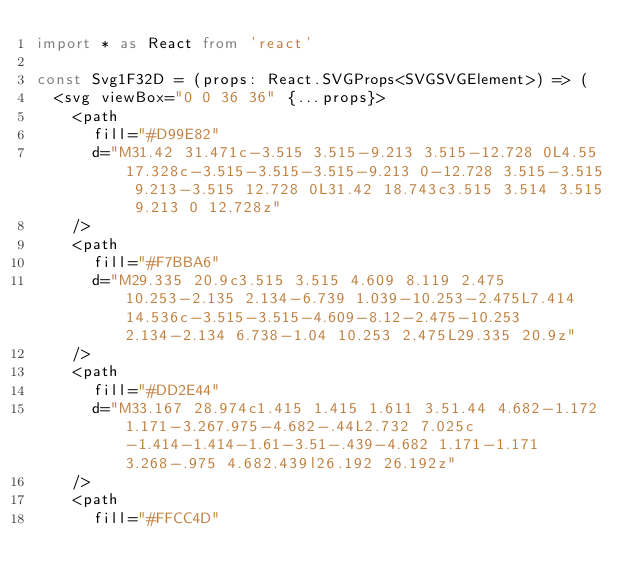Convert code to text. <code><loc_0><loc_0><loc_500><loc_500><_TypeScript_>import * as React from 'react'

const Svg1F32D = (props: React.SVGProps<SVGSVGElement>) => (
  <svg viewBox="0 0 36 36" {...props}>
    <path
      fill="#D99E82"
      d="M31.42 31.471c-3.515 3.515-9.213 3.515-12.728 0L4.55 17.328c-3.515-3.515-3.515-9.213 0-12.728 3.515-3.515 9.213-3.515 12.728 0L31.42 18.743c3.515 3.514 3.515 9.213 0 12.728z"
    />
    <path
      fill="#F7BBA6"
      d="M29.335 20.9c3.515 3.515 4.609 8.119 2.475 10.253-2.135 2.134-6.739 1.039-10.253-2.475L7.414 14.536c-3.515-3.515-4.609-8.12-2.475-10.253 2.134-2.134 6.738-1.04 10.253 2.475L29.335 20.9z"
    />
    <path
      fill="#DD2E44"
      d="M33.167 28.974c1.415 1.415 1.611 3.51.44 4.682-1.172 1.171-3.267.975-4.682-.44L2.732 7.025c-1.414-1.414-1.61-3.51-.439-4.682 1.171-1.171 3.268-.975 4.682.439l26.192 26.192z"
    />
    <path
      fill="#FFCC4D"</code> 